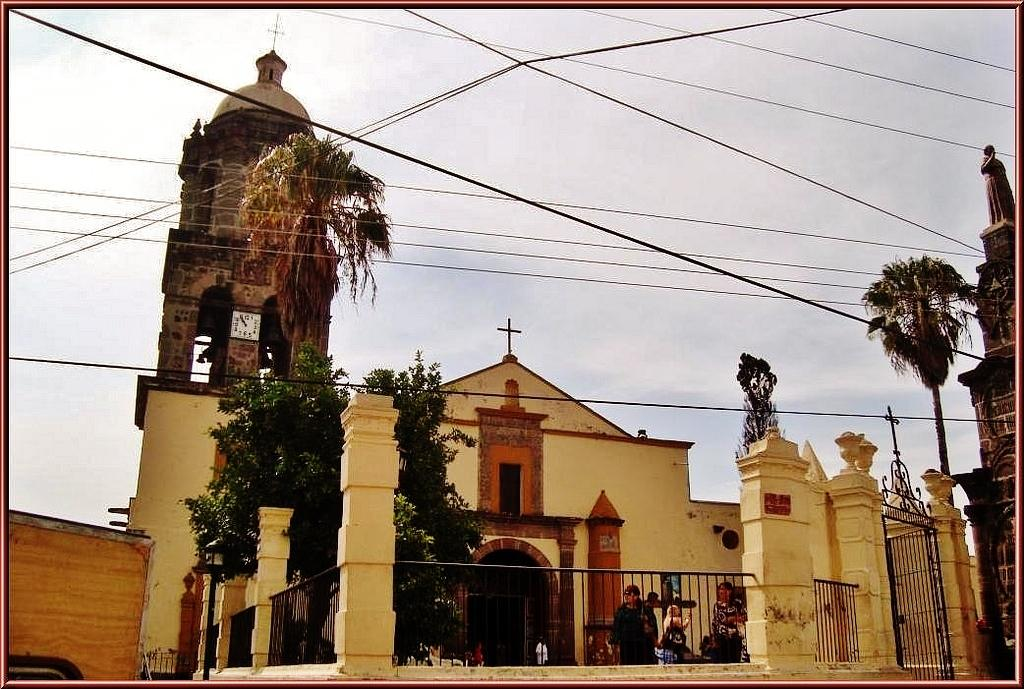What is the main structure in the center of the image? There is a church in the center of the image. Can you describe the people in the image? There are people in the image, but their specific actions or positions are not mentioned in the facts. What other objects or features can be seen in the image? There is a grill, a tower in the background, trees in the background, and wires at the top of the image. What is visible in the background of the image? The sky is visible in the background of the image. What type of vacation is being advertised in the image? There is no indication of a vacation being advertised in the image; it primarily features a church and other elements. What does the church need to be more functional in the image? The facts provided do not mention any specific needs or requirements for the church in the image. 